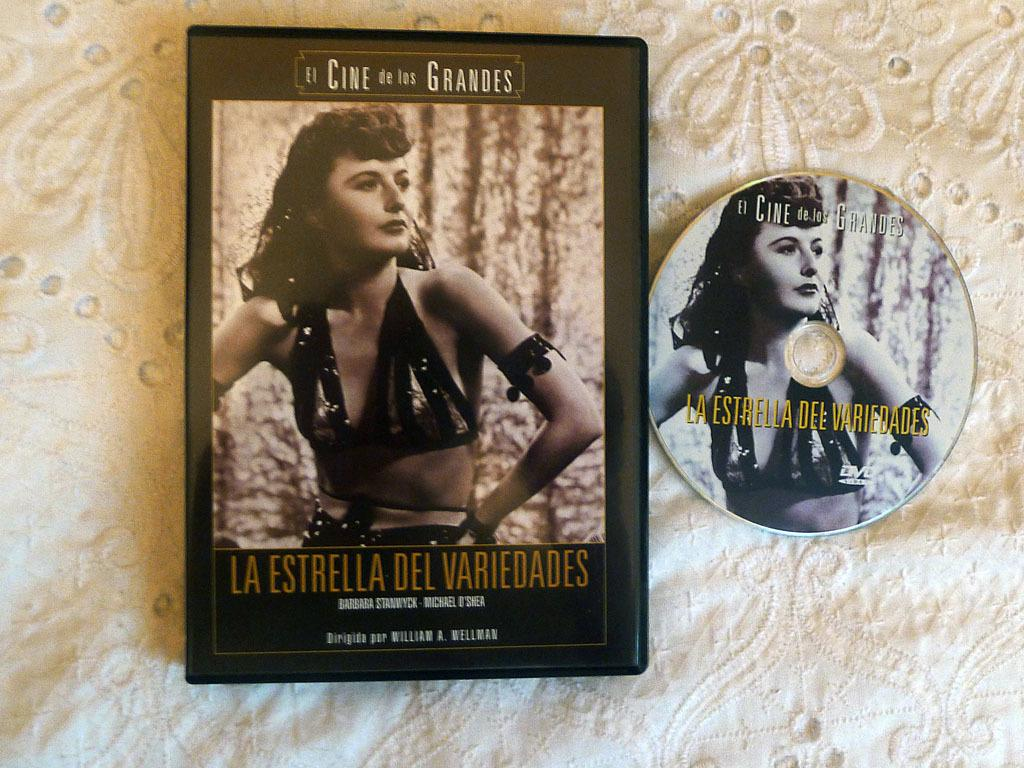What is the main object in the image? There is a board in the image. Is there anyone interacting with the board? Yes, there is a person visible on the board. What can be seen on the board besides the person? There is writing on the board. What is the color of the background in the image? The background color of the image is white. Can you see any smoke coming from the balloon in the image? There is no balloon or smoke present in the image. What type of grain is visible on the board in the image? There is no grain visible on the board in the image. 